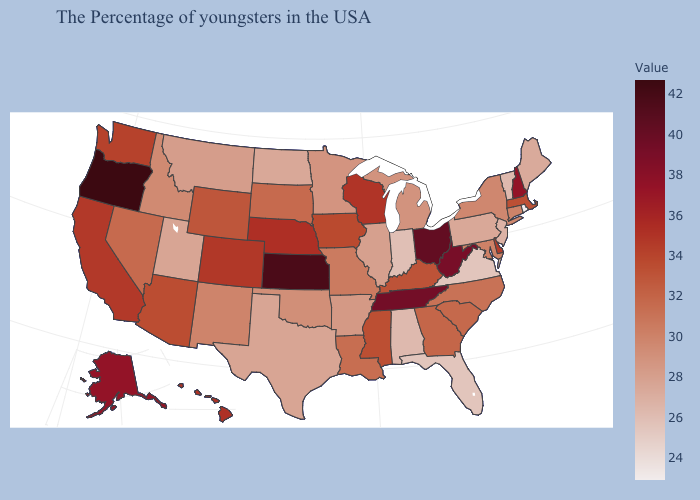Does the map have missing data?
Short answer required. No. Is the legend a continuous bar?
Write a very short answer. Yes. Does Oregon have the highest value in the West?
Quick response, please. Yes. Which states have the lowest value in the Northeast?
Concise answer only. Rhode Island. Among the states that border South Dakota , which have the highest value?
Quick response, please. Nebraska. Does Montana have the highest value in the West?
Give a very brief answer. No. Which states have the highest value in the USA?
Answer briefly. Oregon. Which states hav the highest value in the MidWest?
Answer briefly. Kansas. 